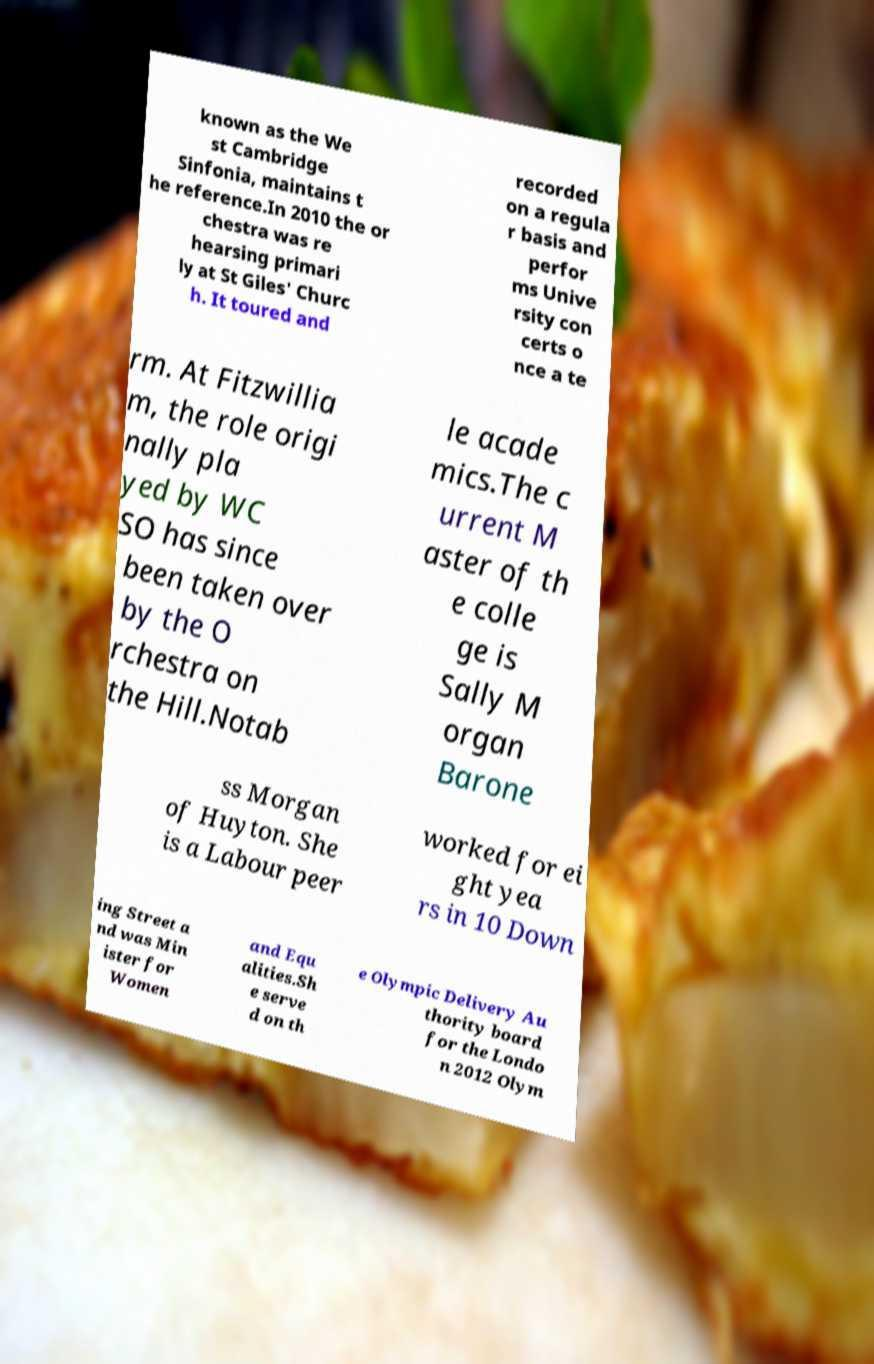There's text embedded in this image that I need extracted. Can you transcribe it verbatim? known as the We st Cambridge Sinfonia, maintains t he reference.In 2010 the or chestra was re hearsing primari ly at St Giles' Churc h. It toured and recorded on a regula r basis and perfor ms Unive rsity con certs o nce a te rm. At Fitzwillia m, the role origi nally pla yed by WC SO has since been taken over by the O rchestra on the Hill.Notab le acade mics.The c urrent M aster of th e colle ge is Sally M organ Barone ss Morgan of Huyton. She is a Labour peer worked for ei ght yea rs in 10 Down ing Street a nd was Min ister for Women and Equ alities.Sh e serve d on th e Olympic Delivery Au thority board for the Londo n 2012 Olym 